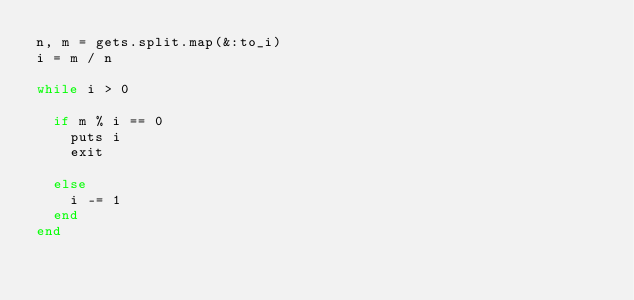<code> <loc_0><loc_0><loc_500><loc_500><_Ruby_>n, m = gets.split.map(&:to_i)
i = m / n
 
while i > 0
  
  if m % i == 0
    puts i
    exit
    
  else
    i -= 1
  end
end</code> 